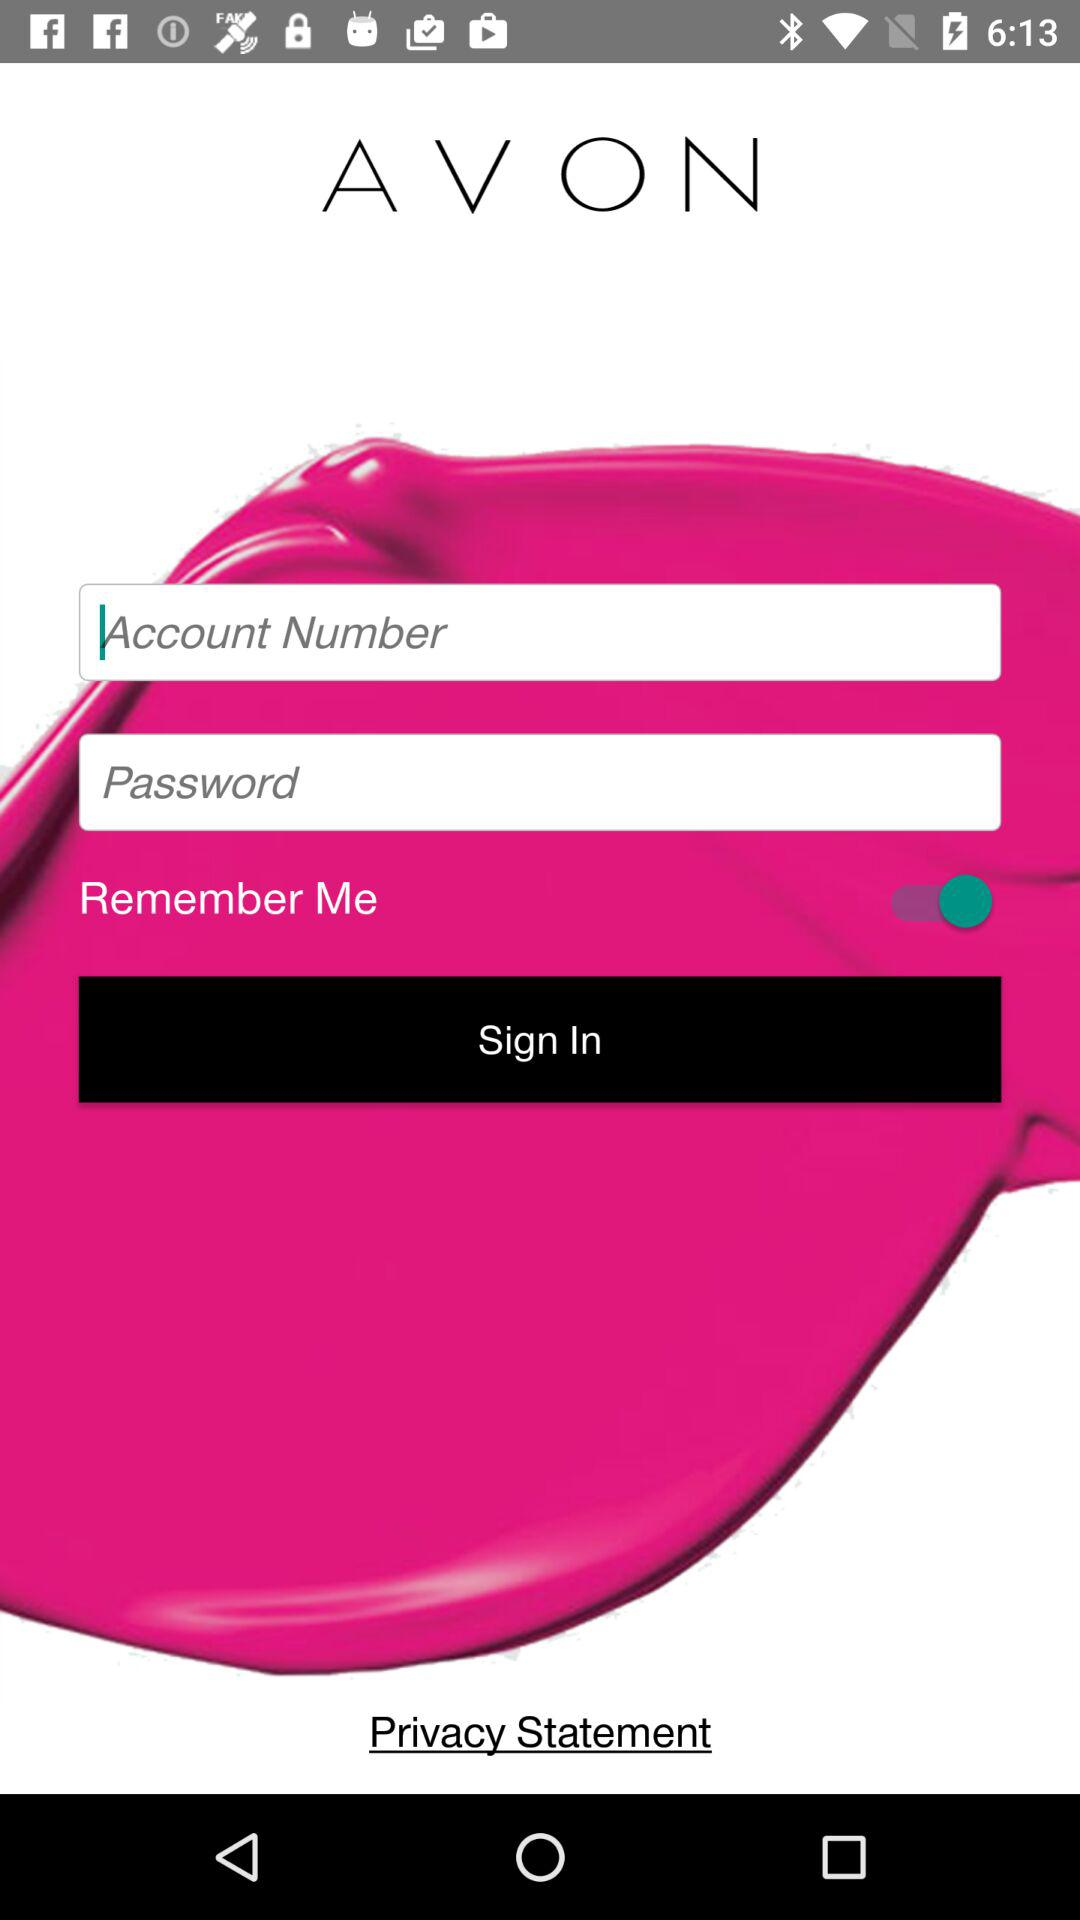What is the current status of "Remember Me"? The current status is "on". 